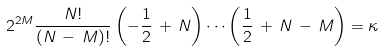Convert formula to latex. <formula><loc_0><loc_0><loc_500><loc_500>2 ^ { 2 M } \frac { N ! } { ( N \, - \, M ) ! } \left ( - \frac { 1 } { 2 } \, + \, N \right ) \cdots \left ( \frac { 1 } { 2 } \, + \, N \, - \, M \right ) = \kappa</formula> 